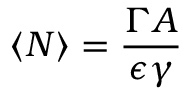<formula> <loc_0><loc_0><loc_500><loc_500>\langle N \rangle = \frac { \Gamma A } { \epsilon \gamma }</formula> 